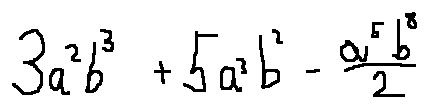<formula> <loc_0><loc_0><loc_500><loc_500>3 a ^ { 2 } b ^ { 3 } + 5 a ^ { 3 } b ^ { 2 } - \frac { a ^ { 5 } b ^ { 8 } } { 2 }</formula> 